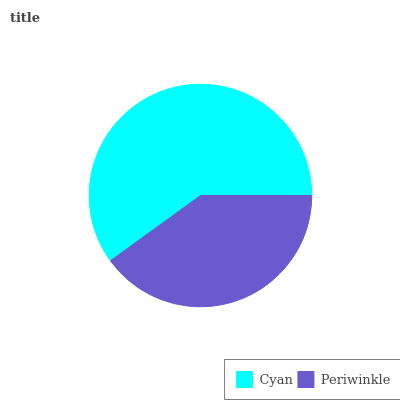Is Periwinkle the minimum?
Answer yes or no. Yes. Is Cyan the maximum?
Answer yes or no. Yes. Is Periwinkle the maximum?
Answer yes or no. No. Is Cyan greater than Periwinkle?
Answer yes or no. Yes. Is Periwinkle less than Cyan?
Answer yes or no. Yes. Is Periwinkle greater than Cyan?
Answer yes or no. No. Is Cyan less than Periwinkle?
Answer yes or no. No. Is Cyan the high median?
Answer yes or no. Yes. Is Periwinkle the low median?
Answer yes or no. Yes. Is Periwinkle the high median?
Answer yes or no. No. Is Cyan the low median?
Answer yes or no. No. 